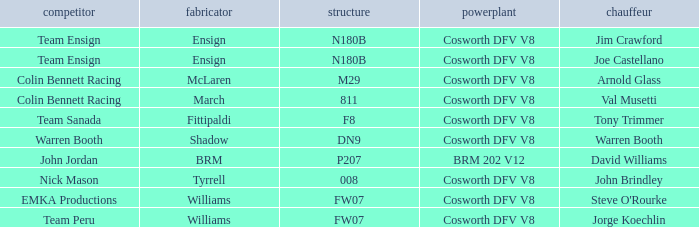What team uses a Cosworth DFV V8 engine and DN9 Chassis? Warren Booth. 